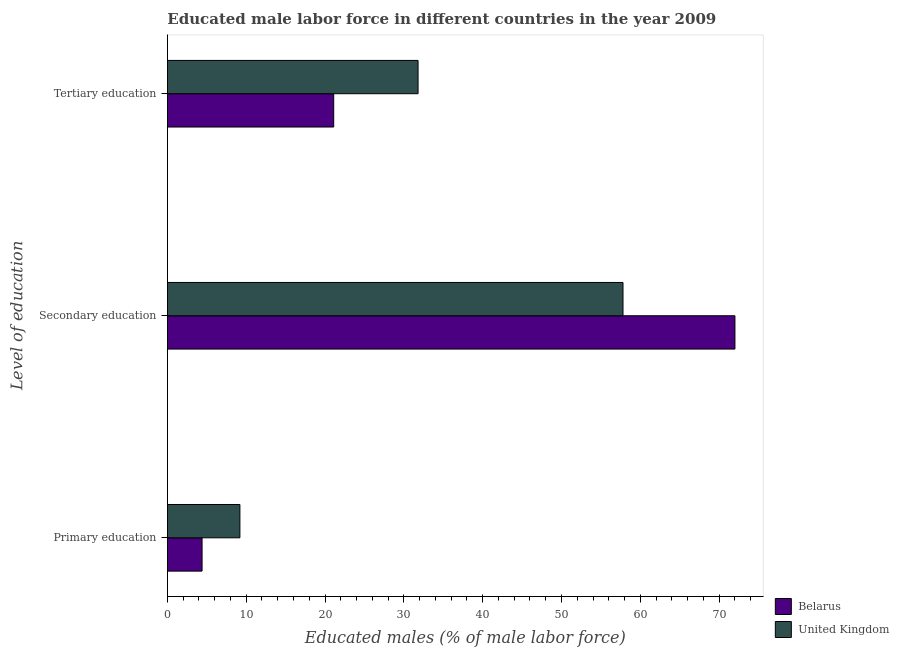How many different coloured bars are there?
Make the answer very short. 2. Are the number of bars per tick equal to the number of legend labels?
Offer a very short reply. Yes. How many bars are there on the 1st tick from the bottom?
Ensure brevity in your answer.  2. What is the label of the 2nd group of bars from the top?
Your response must be concise. Secondary education. Across all countries, what is the maximum percentage of male labor force who received secondary education?
Your answer should be very brief. 72. Across all countries, what is the minimum percentage of male labor force who received secondary education?
Your response must be concise. 57.8. In which country was the percentage of male labor force who received secondary education minimum?
Make the answer very short. United Kingdom. What is the total percentage of male labor force who received primary education in the graph?
Give a very brief answer. 13.6. What is the difference between the percentage of male labor force who received primary education in Belarus and that in United Kingdom?
Your answer should be very brief. -4.8. What is the difference between the percentage of male labor force who received secondary education in United Kingdom and the percentage of male labor force who received tertiary education in Belarus?
Your response must be concise. 36.7. What is the average percentage of male labor force who received primary education per country?
Ensure brevity in your answer.  6.8. What is the difference between the percentage of male labor force who received primary education and percentage of male labor force who received secondary education in United Kingdom?
Offer a terse response. -48.6. What is the ratio of the percentage of male labor force who received tertiary education in Belarus to that in United Kingdom?
Make the answer very short. 0.66. What is the difference between the highest and the second highest percentage of male labor force who received secondary education?
Offer a very short reply. 14.2. What is the difference between the highest and the lowest percentage of male labor force who received primary education?
Your answer should be very brief. 4.8. What does the 1st bar from the bottom in Tertiary education represents?
Offer a very short reply. Belarus. How many countries are there in the graph?
Provide a succinct answer. 2. What is the difference between two consecutive major ticks on the X-axis?
Give a very brief answer. 10. Are the values on the major ticks of X-axis written in scientific E-notation?
Offer a terse response. No. Does the graph contain grids?
Provide a short and direct response. No. How many legend labels are there?
Provide a short and direct response. 2. How are the legend labels stacked?
Your answer should be very brief. Vertical. What is the title of the graph?
Provide a short and direct response. Educated male labor force in different countries in the year 2009. Does "Romania" appear as one of the legend labels in the graph?
Make the answer very short. No. What is the label or title of the X-axis?
Ensure brevity in your answer.  Educated males (% of male labor force). What is the label or title of the Y-axis?
Your answer should be very brief. Level of education. What is the Educated males (% of male labor force) of Belarus in Primary education?
Offer a terse response. 4.4. What is the Educated males (% of male labor force) in United Kingdom in Primary education?
Provide a short and direct response. 9.2. What is the Educated males (% of male labor force) in United Kingdom in Secondary education?
Make the answer very short. 57.8. What is the Educated males (% of male labor force) of Belarus in Tertiary education?
Make the answer very short. 21.1. What is the Educated males (% of male labor force) in United Kingdom in Tertiary education?
Keep it short and to the point. 31.8. Across all Level of education, what is the maximum Educated males (% of male labor force) in United Kingdom?
Give a very brief answer. 57.8. Across all Level of education, what is the minimum Educated males (% of male labor force) of Belarus?
Provide a succinct answer. 4.4. Across all Level of education, what is the minimum Educated males (% of male labor force) of United Kingdom?
Provide a short and direct response. 9.2. What is the total Educated males (% of male labor force) in Belarus in the graph?
Offer a very short reply. 97.5. What is the total Educated males (% of male labor force) of United Kingdom in the graph?
Make the answer very short. 98.8. What is the difference between the Educated males (% of male labor force) in Belarus in Primary education and that in Secondary education?
Keep it short and to the point. -67.6. What is the difference between the Educated males (% of male labor force) of United Kingdom in Primary education and that in Secondary education?
Your answer should be compact. -48.6. What is the difference between the Educated males (% of male labor force) in Belarus in Primary education and that in Tertiary education?
Make the answer very short. -16.7. What is the difference between the Educated males (% of male labor force) in United Kingdom in Primary education and that in Tertiary education?
Give a very brief answer. -22.6. What is the difference between the Educated males (% of male labor force) of Belarus in Secondary education and that in Tertiary education?
Make the answer very short. 50.9. What is the difference between the Educated males (% of male labor force) of United Kingdom in Secondary education and that in Tertiary education?
Keep it short and to the point. 26. What is the difference between the Educated males (% of male labor force) in Belarus in Primary education and the Educated males (% of male labor force) in United Kingdom in Secondary education?
Make the answer very short. -53.4. What is the difference between the Educated males (% of male labor force) in Belarus in Primary education and the Educated males (% of male labor force) in United Kingdom in Tertiary education?
Offer a terse response. -27.4. What is the difference between the Educated males (% of male labor force) of Belarus in Secondary education and the Educated males (% of male labor force) of United Kingdom in Tertiary education?
Your response must be concise. 40.2. What is the average Educated males (% of male labor force) in Belarus per Level of education?
Your response must be concise. 32.5. What is the average Educated males (% of male labor force) of United Kingdom per Level of education?
Offer a terse response. 32.93. What is the difference between the Educated males (% of male labor force) in Belarus and Educated males (% of male labor force) in United Kingdom in Secondary education?
Provide a short and direct response. 14.2. What is the ratio of the Educated males (% of male labor force) in Belarus in Primary education to that in Secondary education?
Give a very brief answer. 0.06. What is the ratio of the Educated males (% of male labor force) of United Kingdom in Primary education to that in Secondary education?
Give a very brief answer. 0.16. What is the ratio of the Educated males (% of male labor force) of Belarus in Primary education to that in Tertiary education?
Give a very brief answer. 0.21. What is the ratio of the Educated males (% of male labor force) in United Kingdom in Primary education to that in Tertiary education?
Ensure brevity in your answer.  0.29. What is the ratio of the Educated males (% of male labor force) in Belarus in Secondary education to that in Tertiary education?
Offer a terse response. 3.41. What is the ratio of the Educated males (% of male labor force) in United Kingdom in Secondary education to that in Tertiary education?
Your answer should be compact. 1.82. What is the difference between the highest and the second highest Educated males (% of male labor force) of Belarus?
Your answer should be compact. 50.9. What is the difference between the highest and the lowest Educated males (% of male labor force) in Belarus?
Ensure brevity in your answer.  67.6. What is the difference between the highest and the lowest Educated males (% of male labor force) in United Kingdom?
Your answer should be compact. 48.6. 